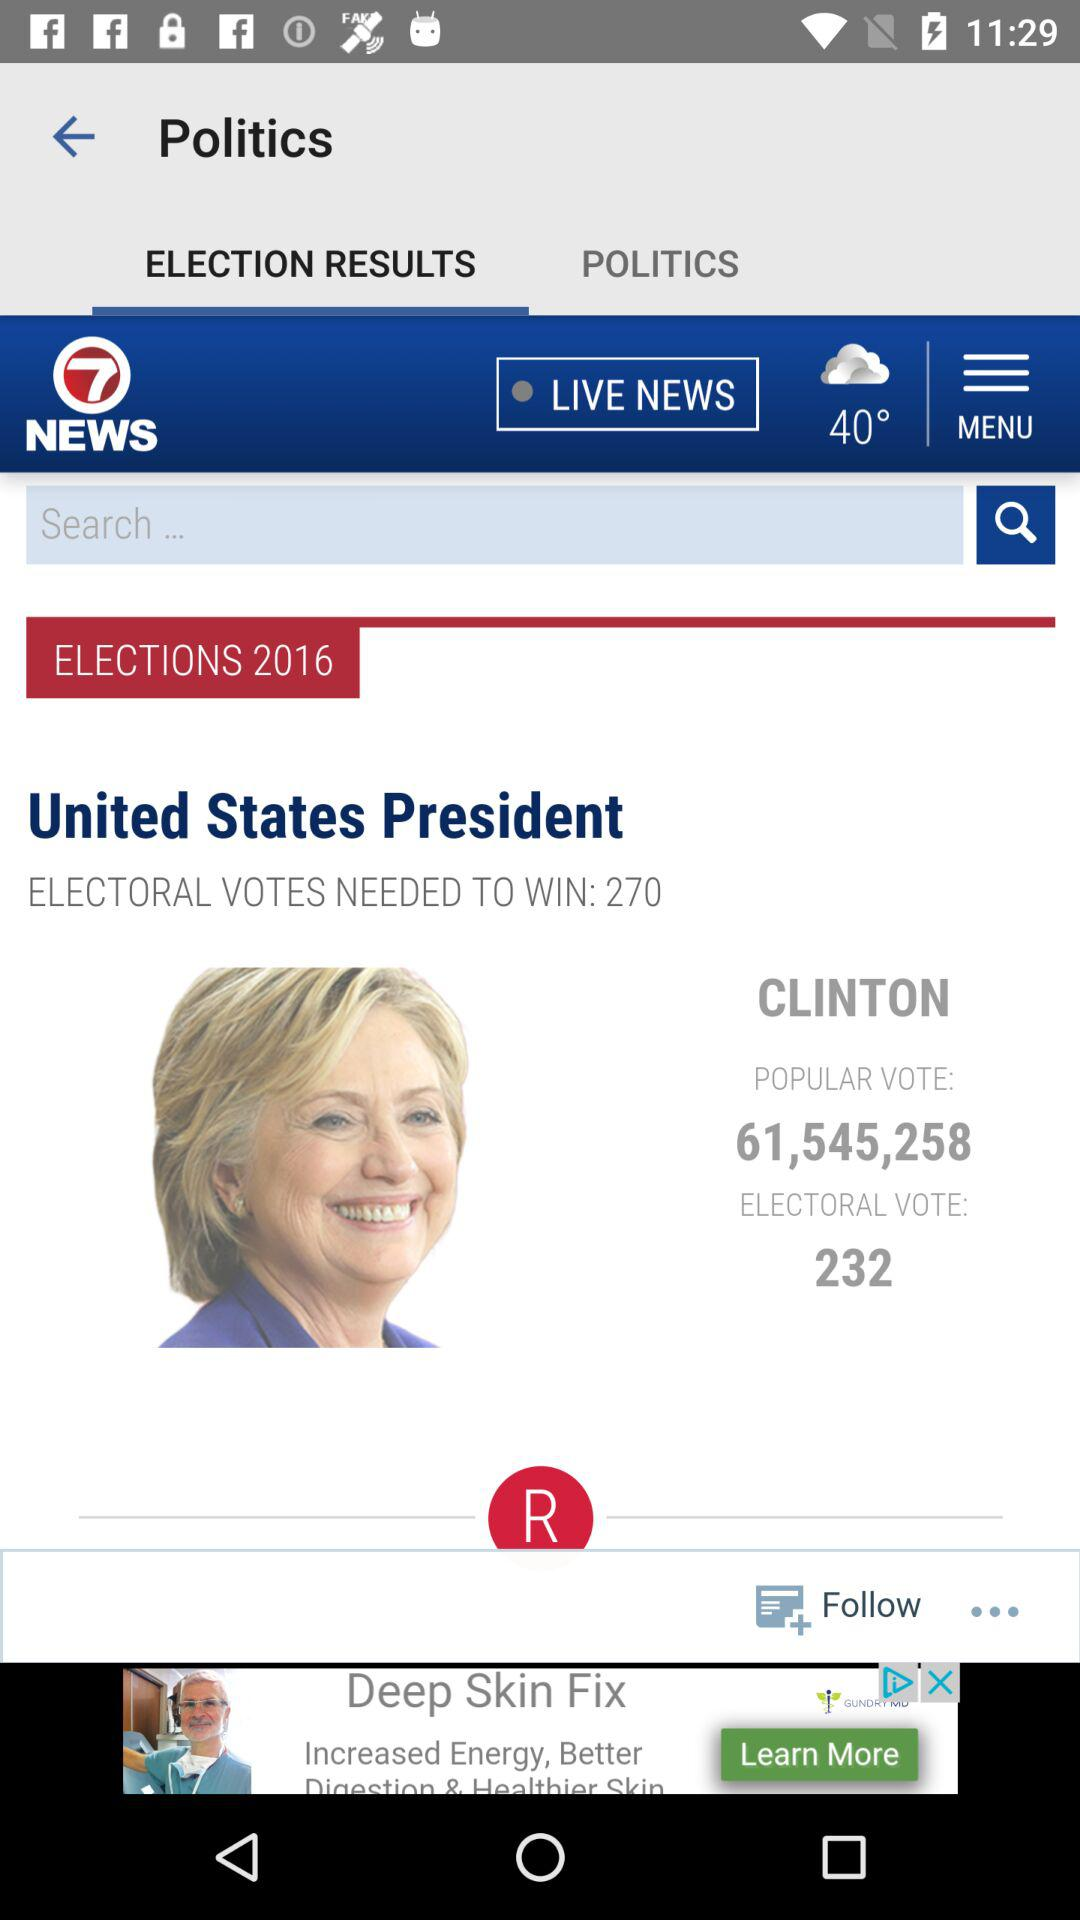Which tab is selected? The tab "ELECTION RESULTS" is selected. 